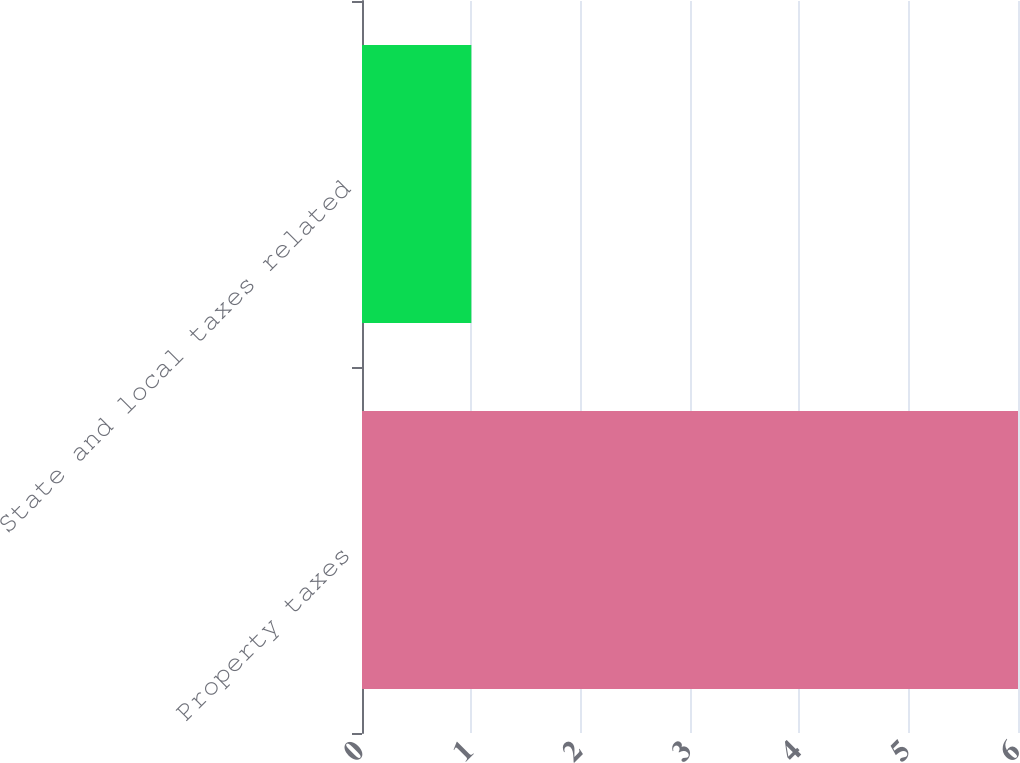Convert chart. <chart><loc_0><loc_0><loc_500><loc_500><bar_chart><fcel>Property taxes<fcel>State and local taxes related<nl><fcel>6<fcel>1<nl></chart> 